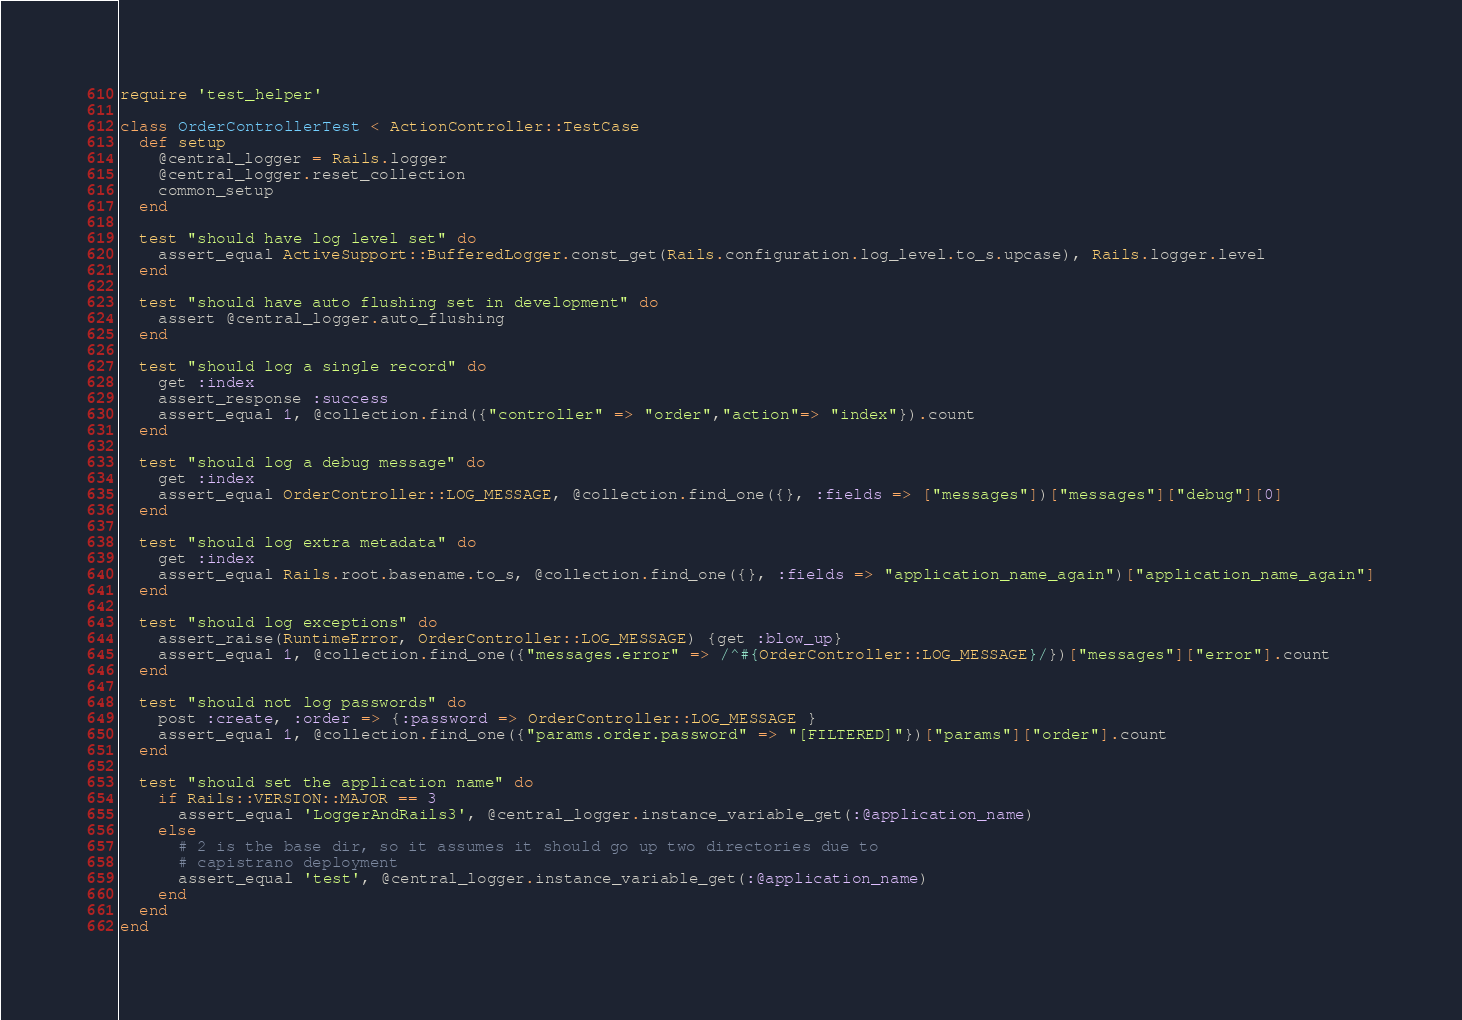<code> <loc_0><loc_0><loc_500><loc_500><_Ruby_>require 'test_helper'

class OrderControllerTest < ActionController::TestCase
  def setup
    @central_logger = Rails.logger
    @central_logger.reset_collection
    common_setup
  end

  test "should have log level set" do
    assert_equal ActiveSupport::BufferedLogger.const_get(Rails.configuration.log_level.to_s.upcase), Rails.logger.level
  end

  test "should have auto flushing set in development" do
    assert @central_logger.auto_flushing
  end

  test "should log a single record" do
    get :index
    assert_response :success
    assert_equal 1, @collection.find({"controller" => "order","action"=> "index"}).count
  end

  test "should log a debug message" do
    get :index
    assert_equal OrderController::LOG_MESSAGE, @collection.find_one({}, :fields => ["messages"])["messages"]["debug"][0]
  end

  test "should log extra metadata" do
    get :index
    assert_equal Rails.root.basename.to_s, @collection.find_one({}, :fields => "application_name_again")["application_name_again"]
  end

  test "should log exceptions" do
    assert_raise(RuntimeError, OrderController::LOG_MESSAGE) {get :blow_up}
    assert_equal 1, @collection.find_one({"messages.error" => /^#{OrderController::LOG_MESSAGE}/})["messages"]["error"].count
  end

  test "should not log passwords" do
    post :create, :order => {:password => OrderController::LOG_MESSAGE }
    assert_equal 1, @collection.find_one({"params.order.password" => "[FILTERED]"})["params"]["order"].count
  end

  test "should set the application name" do
    if Rails::VERSION::MAJOR == 3
      assert_equal 'LoggerAndRails3', @central_logger.instance_variable_get(:@application_name)
    else
      # 2 is the base dir, so it assumes it should go up two directories due to
      # capistrano deployment
      assert_equal 'test', @central_logger.instance_variable_get(:@application_name)
    end
  end
end
</code> 